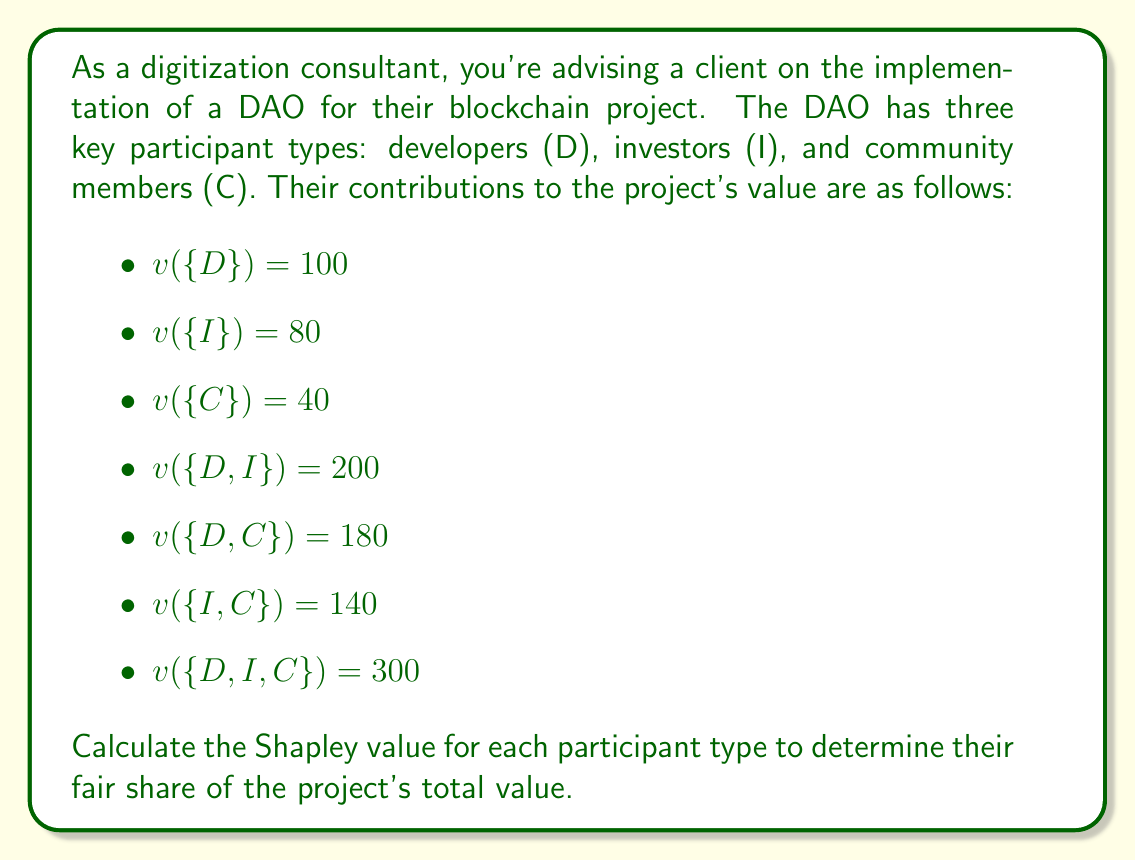Show me your answer to this math problem. To calculate the Shapley value for each participant type, we need to follow these steps:

1. List all possible permutations of the participants.
2. Calculate the marginal contribution of each participant in each permutation.
3. Average the marginal contributions for each participant.

Step 1: List all possible permutations
1. D, I, C
2. D, C, I
3. I, D, C
4. I, C, D
5. C, D, I
6. C, I, D

Step 2: Calculate marginal contributions

For Developers (D):
1. D, I, C: $100$
2. D, C, I: $100$
3. I, D, C: $120$ ($200 - 80$)
4. I, C, D: $160$ ($300 - 140$)
5. C, D, I: $140$ ($180 - 40$)
6. C, I, D: $160$ ($300 - 140$)

For Investors (I):
1. D, I, C: $100$ ($200 - 100$)
2. D, C, I: $120$ ($300 - 180$)
3. I, D, C: $80$
4. I, C, D: $80$
5. C, D, I: $120$ ($300 - 180$)
6. C, I, D: $100$ ($140 - 40$)

For Community Members (C):
1. D, I, C: $100$ ($300 - 200$)
2. D, C, I: $80$ ($180 - 100$)
3. I, D, C: $100$ ($300 - 200$)
4. I, C, D: $60$ ($140 - 80$)
5. C, D, I: $40$
6. C, I, D: $40$

Step 3: Average the marginal contributions

Developers (D): $\frac{100 + 100 + 120 + 160 + 140 + 160}{6} = \frac{780}{6} = 130$

Investors (I): $\frac{100 + 120 + 80 + 80 + 120 + 100}{6} = \frac{600}{6} = 100$

Community Members (C): $\frac{100 + 80 + 100 + 60 + 40 + 40}{6} = \frac{420}{6} = 70$

The Shapley value for each participant type represents their fair share of the project's total value based on their marginal contributions.
Answer: The Shapley values for each participant type are:

Developers (D): $130$
Investors (I): $100$
Community Members (C): $70$ 